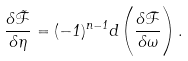Convert formula to latex. <formula><loc_0><loc_0><loc_500><loc_500>\frac { \delta \tilde { \mathcal { F } } } { \delta \eta } = ( - 1 ) ^ { n - 1 } d \left ( \frac { \delta \bar { \mathcal { F } } } { \delta \omega } \right ) .</formula> 